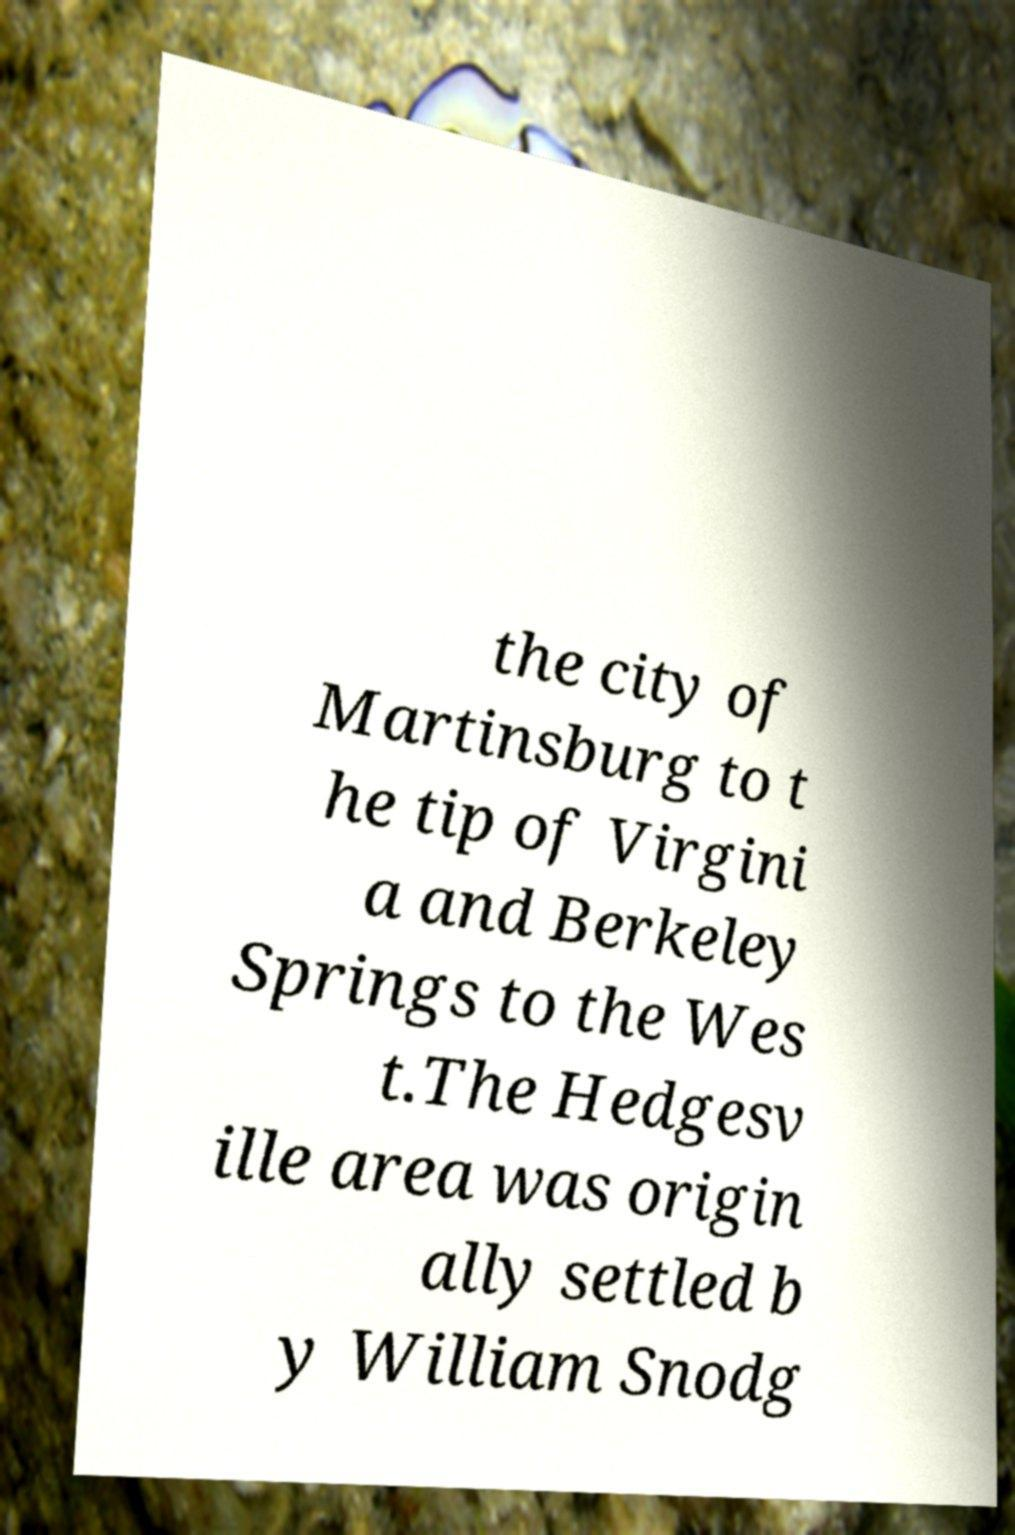Can you accurately transcribe the text from the provided image for me? the city of Martinsburg to t he tip of Virgini a and Berkeley Springs to the Wes t.The Hedgesv ille area was origin ally settled b y William Snodg 